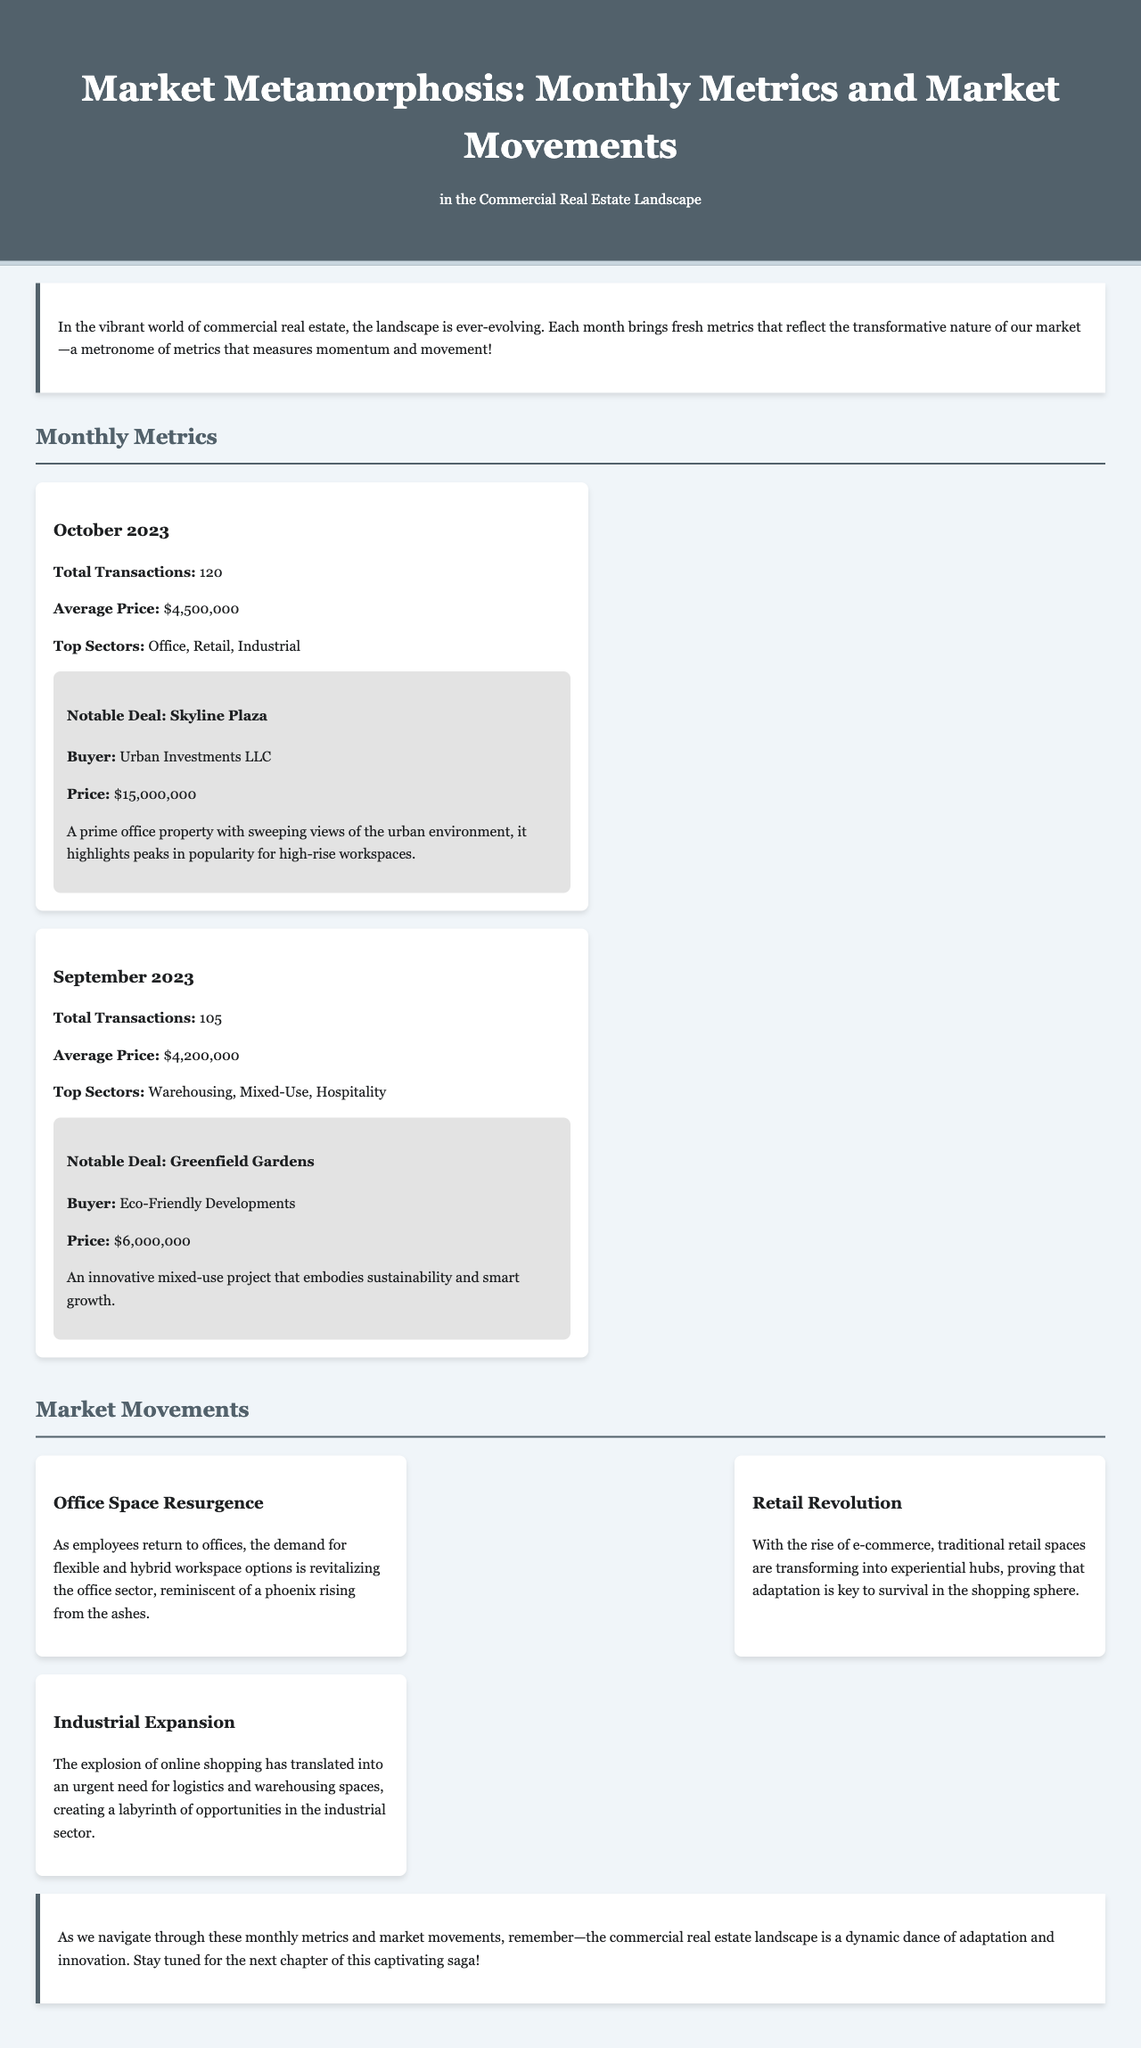What was the total number of transactions in October 2023? The total transactions in October 2023 are explicitly provided in the metrics section, which lists 120 transactions.
Answer: 120 What is the average price of transactions in September 2023? The document specifies that the average price for September 2023 is detailed in the metrics section, showing $4,200,000.
Answer: $4,200,000 Which sector was most notable in transactions for October 2023? The top sectors for October 2023 are mentioned, identifying Office, Retail, and Industrial as the leading categories.
Answer: Office, Retail, Industrial What notable deal occurred in October 2023? The notable deal for October 2023 is clearly highlighted, naming Skyline Plaza as the significant transaction.
Answer: Skyline Plaza What market trend is associated with the resurgence of office spaces? The trend card discussing office space indicates that the resurgence is likened to a phoenix rising from the ashes, demonstrating a metaphor for revitalization.
Answer: Phoenix rising from the ashes What was the notable deal price for Greenfield Gardens? Greenfield Gardens' deal price is explicitly provided in the notable deal section, which states it was $6,000,000.
Answer: $6,000,000 Which sector is experiencing an industrial expansion? The industrial expansion trend discusses the urgent need for logistics and warehousing spaces, confirming what sector is expanding.
Answer: Industrial What month is highlighted for notable market metrics? The document clearly indicates October 2023 and September 2023 as the months highlighted for detailed market metrics.
Answer: October 2023, September 2023 What is the primary theme of the conclusion? The conclusion underscores the dynamic nature of the commercial real estate landscape, referring to it as a dance of adaptation and innovation.
Answer: Dance of adaptation and innovation 